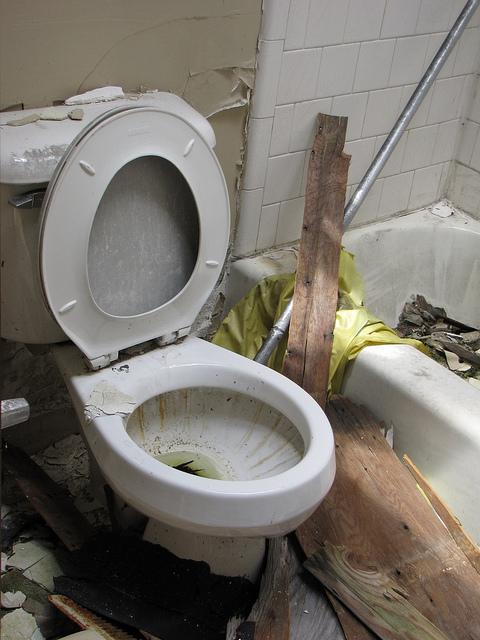How many clock faces are there?
Give a very brief answer. 0. 